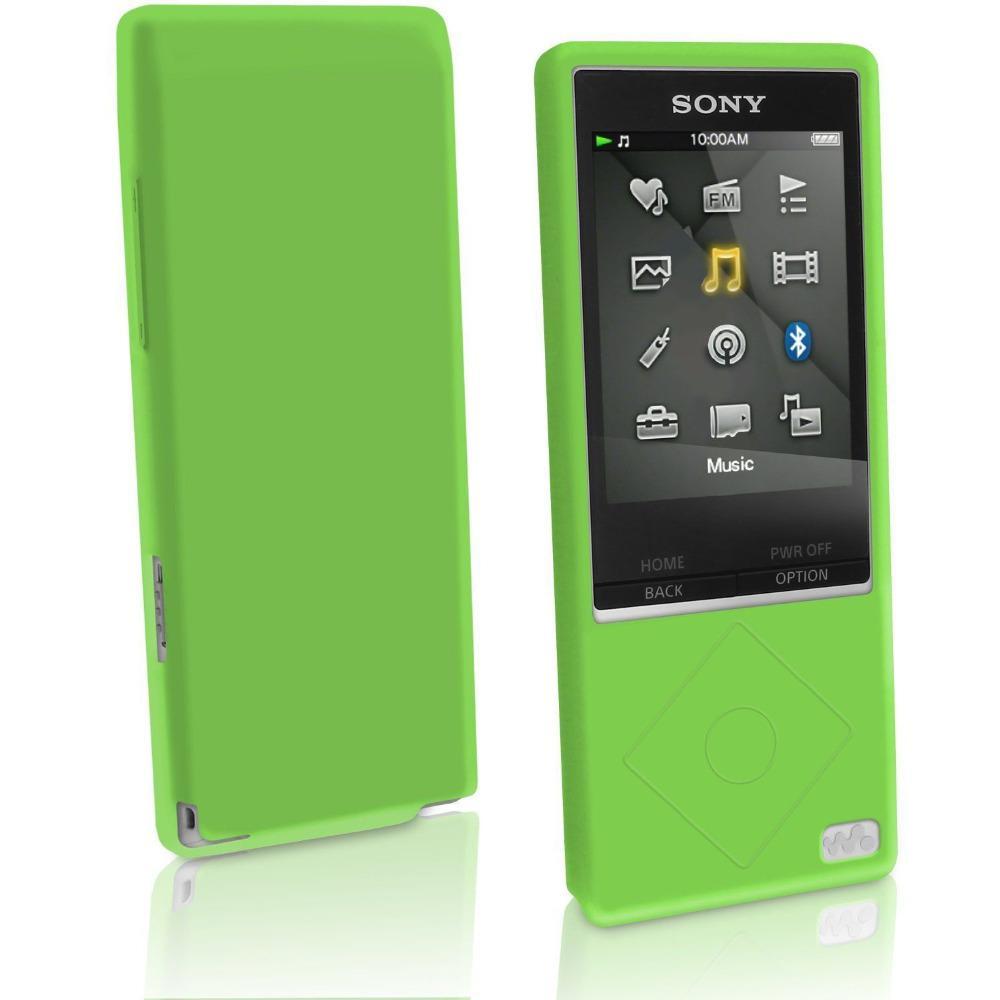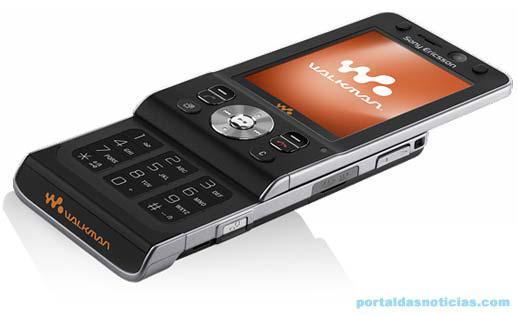The first image is the image on the left, the second image is the image on the right. Analyze the images presented: Is the assertion "One image shows the back of the phone." valid? Answer yes or no. Yes. The first image is the image on the left, the second image is the image on the right. Analyze the images presented: Is the assertion "Each image contains one red device, and at least one of the devices pictured has a round button inside a red diamond shape at the bottom." valid? Answer yes or no. No. 